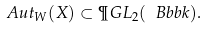Convert formula to latex. <formula><loc_0><loc_0><loc_500><loc_500>\ A u t _ { W } ( X ) \subset \P G L _ { 2 } ( \ B b b k ) .</formula> 